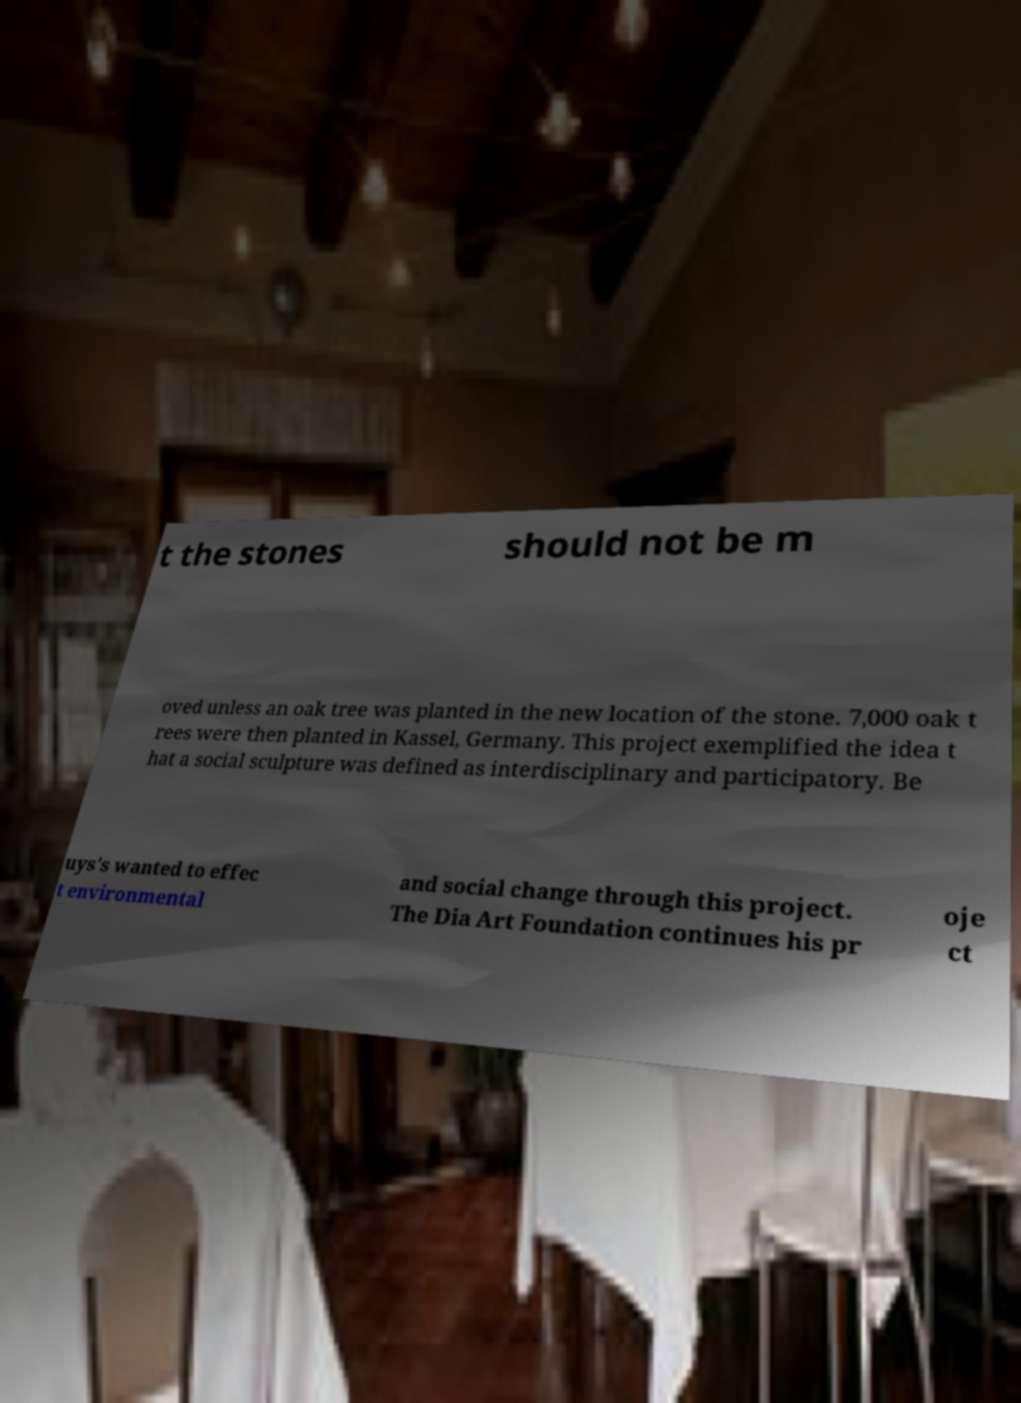Please identify and transcribe the text found in this image. t the stones should not be m oved unless an oak tree was planted in the new location of the stone. 7,000 oak t rees were then planted in Kassel, Germany. This project exemplified the idea t hat a social sculpture was defined as interdisciplinary and participatory. Be uys's wanted to effec t environmental and social change through this project. The Dia Art Foundation continues his pr oje ct 